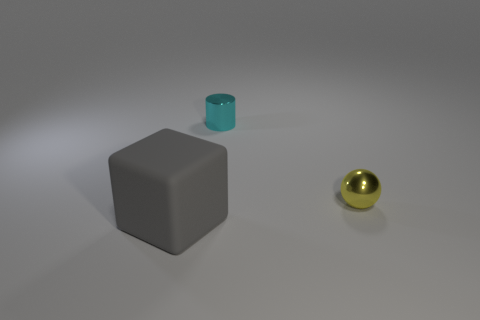There is a cyan metal object; how many gray blocks are behind it?
Offer a terse response. 0. How many green objects are metal balls or tiny metallic cylinders?
Keep it short and to the point. 0. What number of gray matte objects are left of the thing that is to the left of the cyan cylinder?
Ensure brevity in your answer.  0. How many other things are the same shape as the large matte object?
Your answer should be very brief. 0. There is a ball that is the same material as the small cyan cylinder; what color is it?
Your answer should be very brief. Yellow. Is there a purple metallic cylinder that has the same size as the sphere?
Your answer should be very brief. No. Are there more yellow shiny objects to the left of the tiny cyan object than yellow balls that are to the left of the tiny yellow thing?
Provide a succinct answer. No. Is the material of the object that is behind the small yellow metal ball the same as the object in front of the shiny sphere?
Your answer should be compact. No. There is a cyan thing that is the same size as the yellow ball; what shape is it?
Provide a succinct answer. Cylinder. Is there a tiny red metallic thing of the same shape as the tiny yellow metal object?
Offer a terse response. No. 